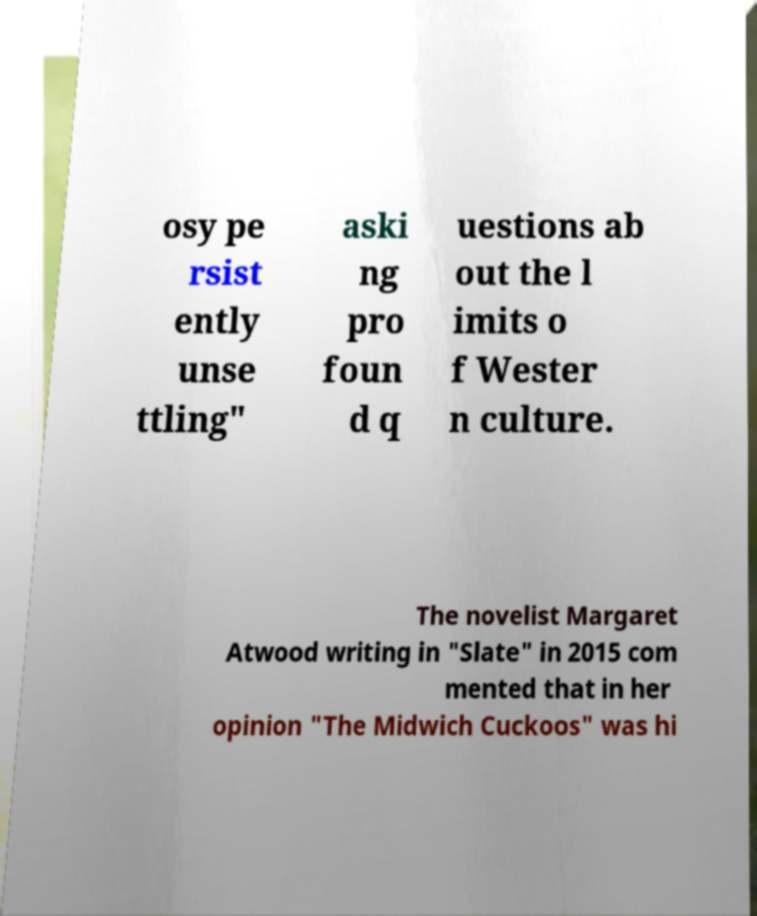Please read and relay the text visible in this image. What does it say? osy pe rsist ently unse ttling" aski ng pro foun d q uestions ab out the l imits o f Wester n culture. The novelist Margaret Atwood writing in "Slate" in 2015 com mented that in her opinion "The Midwich Cuckoos" was hi 